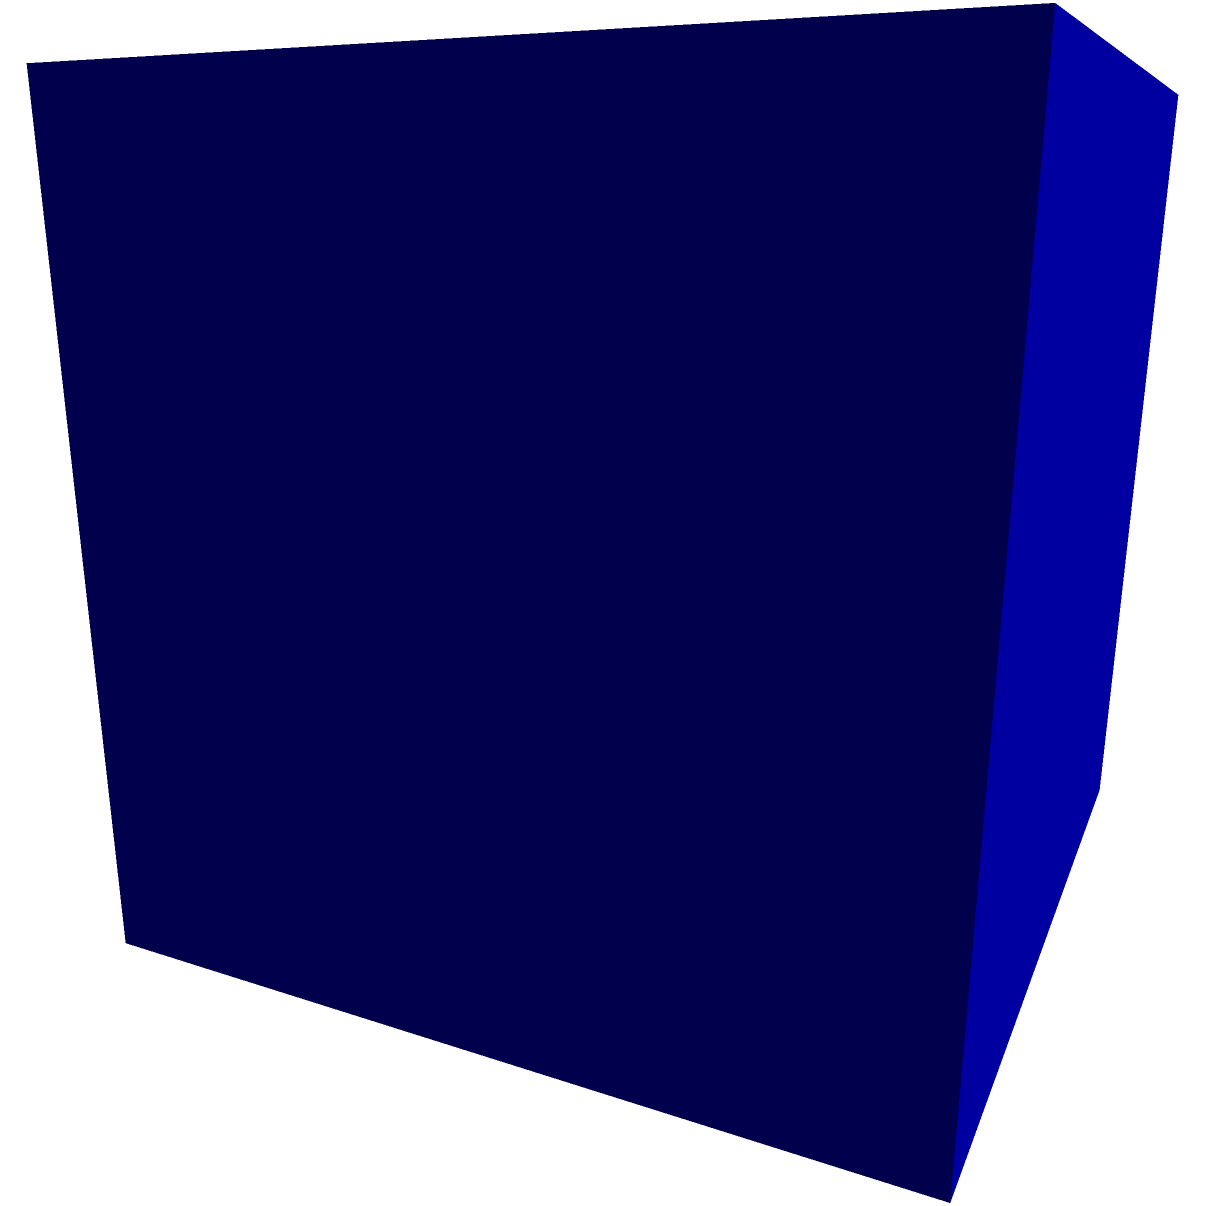You have a display case with dimensions 30 cm × 20 cm × 25 cm. Each replica artifact is a cube with sides of 5 cm. Assuming optimal packing, how many replica artifacts can fit in the display case? To solve this problem, we need to follow these steps:

1. Calculate the volume of the display case:
   $V_{case} = 30 \text{ cm} \times 20 \text{ cm} \times 25 \text{ cm} = 15,000 \text{ cm}^3$

2. Calculate the volume of each replica artifact:
   $V_{artifact} = 5 \text{ cm} \times 5 \text{ cm} \times 5 \text{ cm} = 125 \text{ cm}^3$

3. Calculate the number of artifacts that can fit in each dimension:
   Length: $30 \text{ cm} \div 5 \text{ cm} = 6$ artifacts
   Width: $20 \text{ cm} \div 5 \text{ cm} = 4$ artifacts
   Height: $25 \text{ cm} \div 5 \text{ cm} = 5$ artifacts

4. Multiply the number of artifacts in each dimension:
   $N_{artifacts} = 6 \times 4 \times 5 = 120$ artifacts

Therefore, assuming optimal packing, 120 replica artifacts can fit in the display case.
Answer: 120 artifacts 